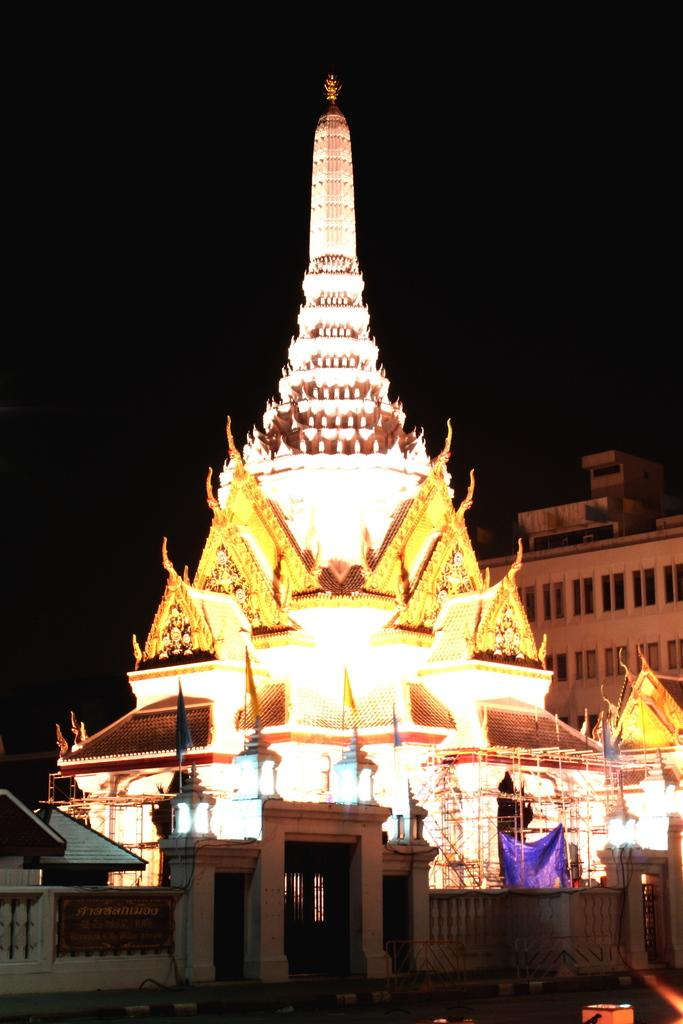What is located in the center of the image? There is a way in the center of the image. What structure is on the right side of the image? There is a building on the right side of the image. What is at the bottom of the image? There is a wall at the bottom of the image. What is associated with the wall? There is a gate associated with the wall. What can be seen in the background of the image? The sky is visible in the background of the image. How many rings are visible on the building in the image? There are no rings visible on the building in the image. What type of observation can be made from the image? The image itself is a visual observation, but there is no specific observation being made in the image. What type of land is depicted in the image? The image does not specifically depict a type of land; it shows a way, a building, a wall, a gate, and the sky. 